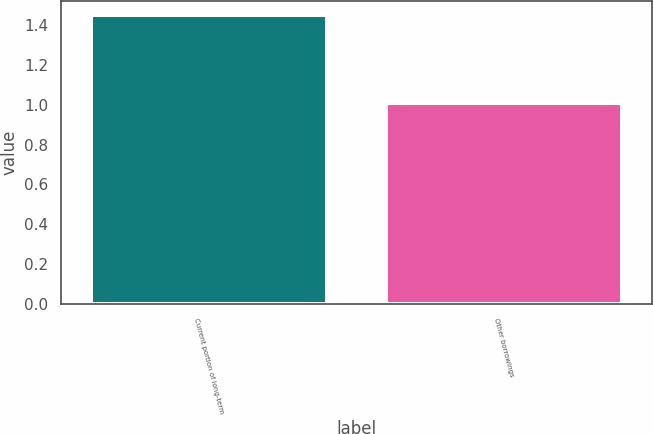Convert chart to OTSL. <chart><loc_0><loc_0><loc_500><loc_500><bar_chart><fcel>Current portion of long-term<fcel>Other borrowings<nl><fcel>1.45<fcel>1.01<nl></chart> 